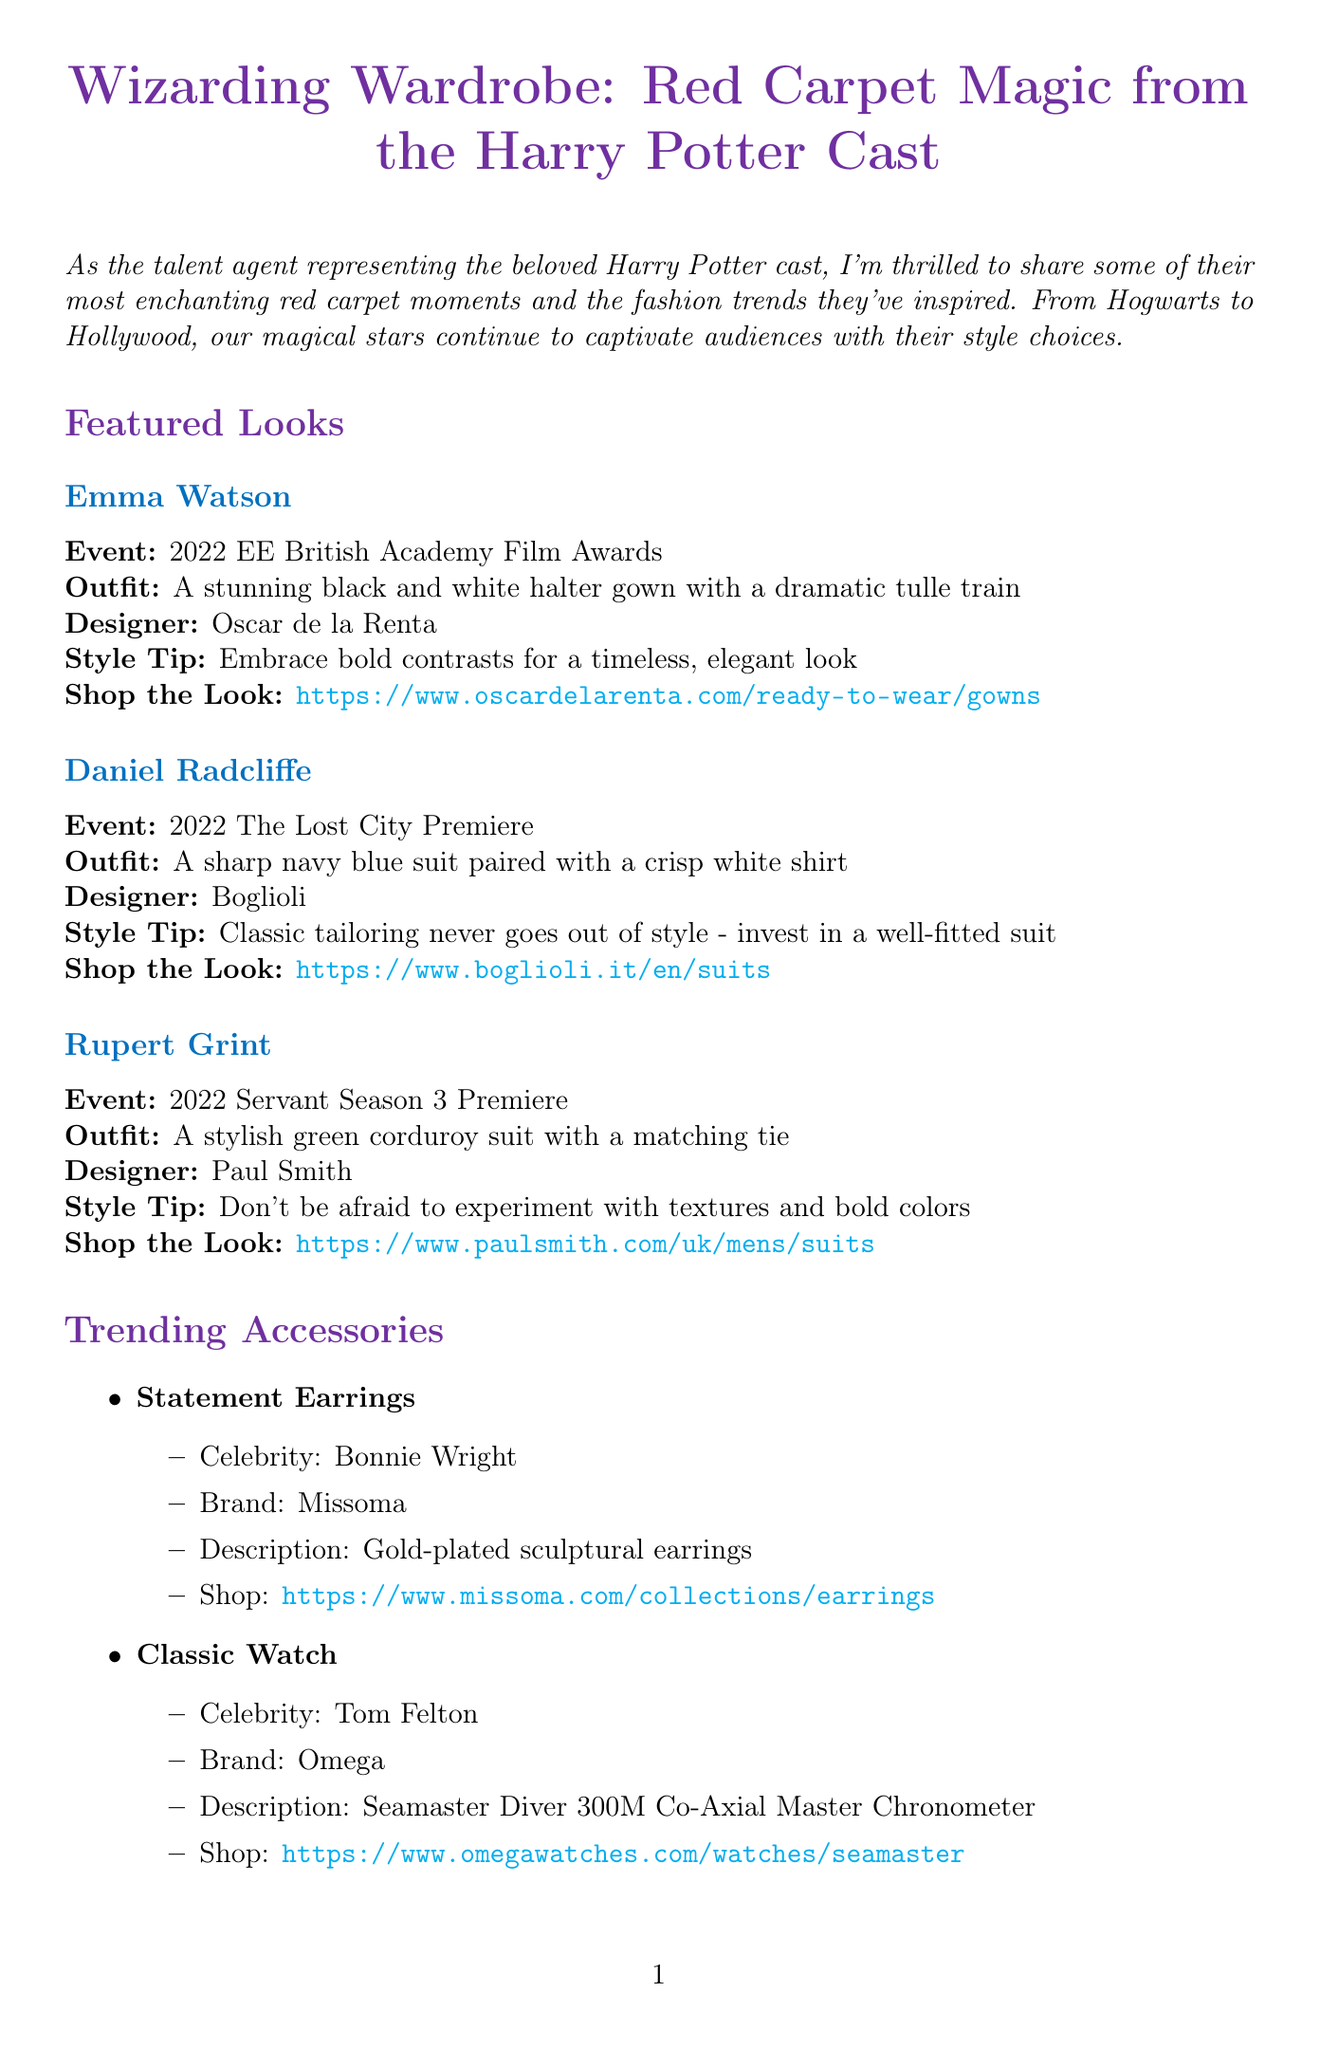What is the title of the newsletter? The title of the newsletter is prominently displayed at the beginning of the document.
Answer: Wizarding Wardrobe: Red Carpet Magic from the Harry Potter Cast Who designed Emma Watson's gown? The document specifically attributes the design of Emma Watson's gown to a notable designer.
Answer: Oscar de la Renta What event did Daniel Radcliffe attend in 2022? The newsletter lists events alongside each actor's featured look, identifying the specific occasion for Daniel Radcliffe.
Answer: The Lost City Premiere Which actress is highlighted for her sustainable fashion initiative? The document offers a spotlight section dedicated to an actor's sustainable fashion efforts, identifying the individual involved.
Answer: Evanna Lynch What type of accessory is featured from Bonnie Wright? The accessories section details specific items along with the respective celebrity, highlighting what Bonnie Wright is showcasing.
Answer: Statement Earrings How many attending cast members are listed for the Met Gala 2023? The document mentions the names of attending cast members for each upcoming event, allowing for easy counting.
Answer: Three What is the date of the Cannes Film Festival 2023? The upcoming events section includes detailed date information for each occasion listed.
Answer: May 16-27, 2023 What brand is associated with the classic watch worn by Tom Felton? The accessories section attributes the watch to a specific renowned brand.
Answer: Omega What do participants need to do to enter the style consultation? The style consultations area outlines the entry requirements clearly.
Answer: Follow @HPCastStyle on Instagram and share your most magical outfit inspired by the Wizarding World 